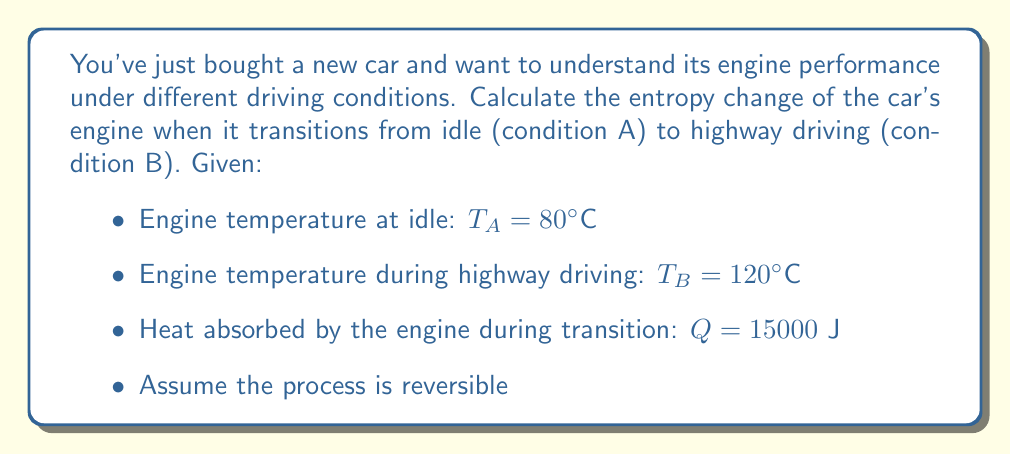Solve this math problem. To calculate the entropy change, we'll use the formula for entropy change in a reversible process:

$$\Delta S = \int_{A}^{B} \frac{dQ}{T}$$

For a process with constant heat flow and temperature change, we can approximate this as:

$$\Delta S = Q \cdot \ln\left(\frac{T_B}{T_A}\right)$$

Step 1: Convert temperatures to Kelvin
$T_A = 80°C + 273.15 = 353.15$ K
$T_B = 120°C + 273.15 = 393.15$ K

Step 2: Plug values into the entropy change formula
$$\Delta S = 15000 \cdot \ln\left(\frac{393.15}{353.15}\right)$$

Step 3: Calculate the natural logarithm
$$\Delta S = 15000 \cdot \ln(1.1133) = 15000 \cdot 0.1073$$

Step 4: Compute the final result
$$\Delta S = 1609.5 \text{ J/K}$$

This positive entropy change indicates that the engine's disorder increases as it transitions from idle to highway driving, which is expected due to the increased heat and work done by the engine.
Answer: $1609.5 \text{ J/K}$ 